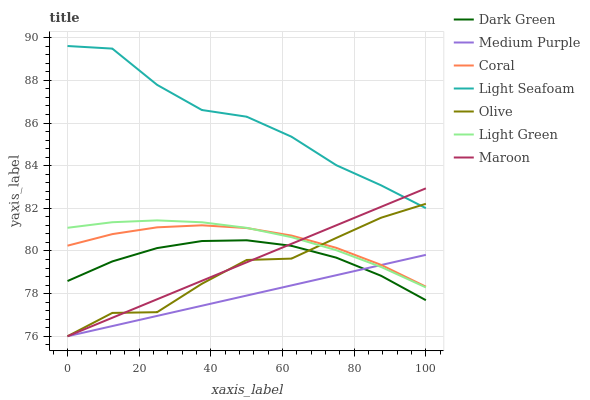Does Medium Purple have the minimum area under the curve?
Answer yes or no. Yes. Does Light Seafoam have the maximum area under the curve?
Answer yes or no. Yes. Does Maroon have the minimum area under the curve?
Answer yes or no. No. Does Maroon have the maximum area under the curve?
Answer yes or no. No. Is Maroon the smoothest?
Answer yes or no. Yes. Is Olive the roughest?
Answer yes or no. Yes. Is Medium Purple the smoothest?
Answer yes or no. No. Is Medium Purple the roughest?
Answer yes or no. No. Does Maroon have the lowest value?
Answer yes or no. Yes. Does Light Green have the lowest value?
Answer yes or no. No. Does Light Seafoam have the highest value?
Answer yes or no. Yes. Does Maroon have the highest value?
Answer yes or no. No. Is Light Green less than Light Seafoam?
Answer yes or no. Yes. Is Light Green greater than Dark Green?
Answer yes or no. Yes. Does Medium Purple intersect Light Green?
Answer yes or no. Yes. Is Medium Purple less than Light Green?
Answer yes or no. No. Is Medium Purple greater than Light Green?
Answer yes or no. No. Does Light Green intersect Light Seafoam?
Answer yes or no. No. 